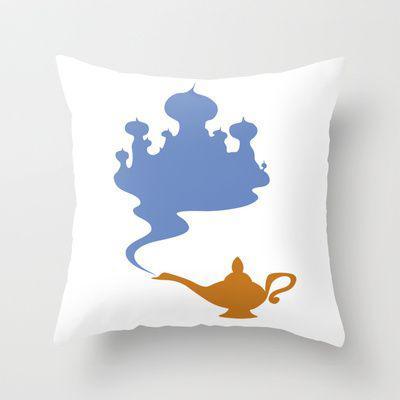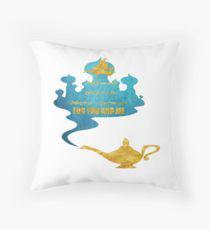The first image is the image on the left, the second image is the image on the right. Considering the images on both sides, is "The lefthand image shows a pillow decorated with at least one symmetrical sky-blue shape that resembles a snowflake." valid? Answer yes or no. No. The first image is the image on the left, the second image is the image on the right. Analyze the images presented: Is the assertion "The pillows in the image on the left have words on them." valid? Answer yes or no. No. 